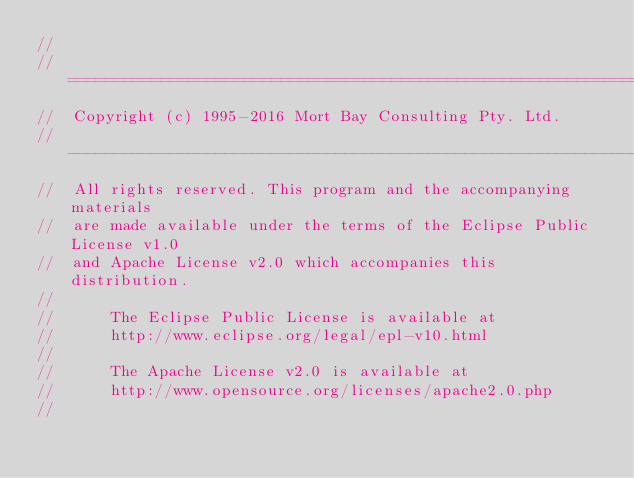Convert code to text. <code><loc_0><loc_0><loc_500><loc_500><_Java_>//
//  ========================================================================
//  Copyright (c) 1995-2016 Mort Bay Consulting Pty. Ltd.
//  ------------------------------------------------------------------------
//  All rights reserved. This program and the accompanying materials
//  are made available under the terms of the Eclipse Public License v1.0
//  and Apache License v2.0 which accompanies this distribution.
//
//      The Eclipse Public License is available at
//      http://www.eclipse.org/legal/epl-v10.html
//
//      The Apache License v2.0 is available at
//      http://www.opensource.org/licenses/apache2.0.php
//</code> 